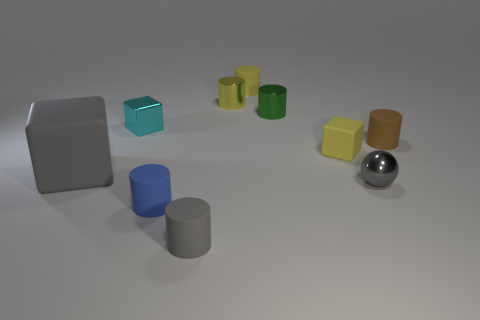Is there anything else that has the same size as the gray rubber cube?
Your answer should be compact. No. Is there any other thing that is the same material as the tiny cyan thing?
Keep it short and to the point. Yes. There is a cube that is to the right of the matte cylinder that is behind the small rubber object that is to the right of the gray metal ball; what is it made of?
Provide a short and direct response. Rubber. There is a big object that is the same color as the sphere; what is it made of?
Give a very brief answer. Rubber. What number of large gray cubes are the same material as the tiny blue cylinder?
Make the answer very short. 1. Does the matte block that is on the right side of the cyan block have the same size as the brown matte object?
Make the answer very short. Yes. What is the color of the block that is made of the same material as the sphere?
Provide a short and direct response. Cyan. There is a small metal sphere; what number of blocks are to the right of it?
Your answer should be very brief. 0. Do the tiny rubber cylinder that is behind the tiny brown matte cylinder and the small shiny object behind the green object have the same color?
Make the answer very short. Yes. There is another large thing that is the same shape as the cyan metallic object; what is its color?
Ensure brevity in your answer.  Gray. 